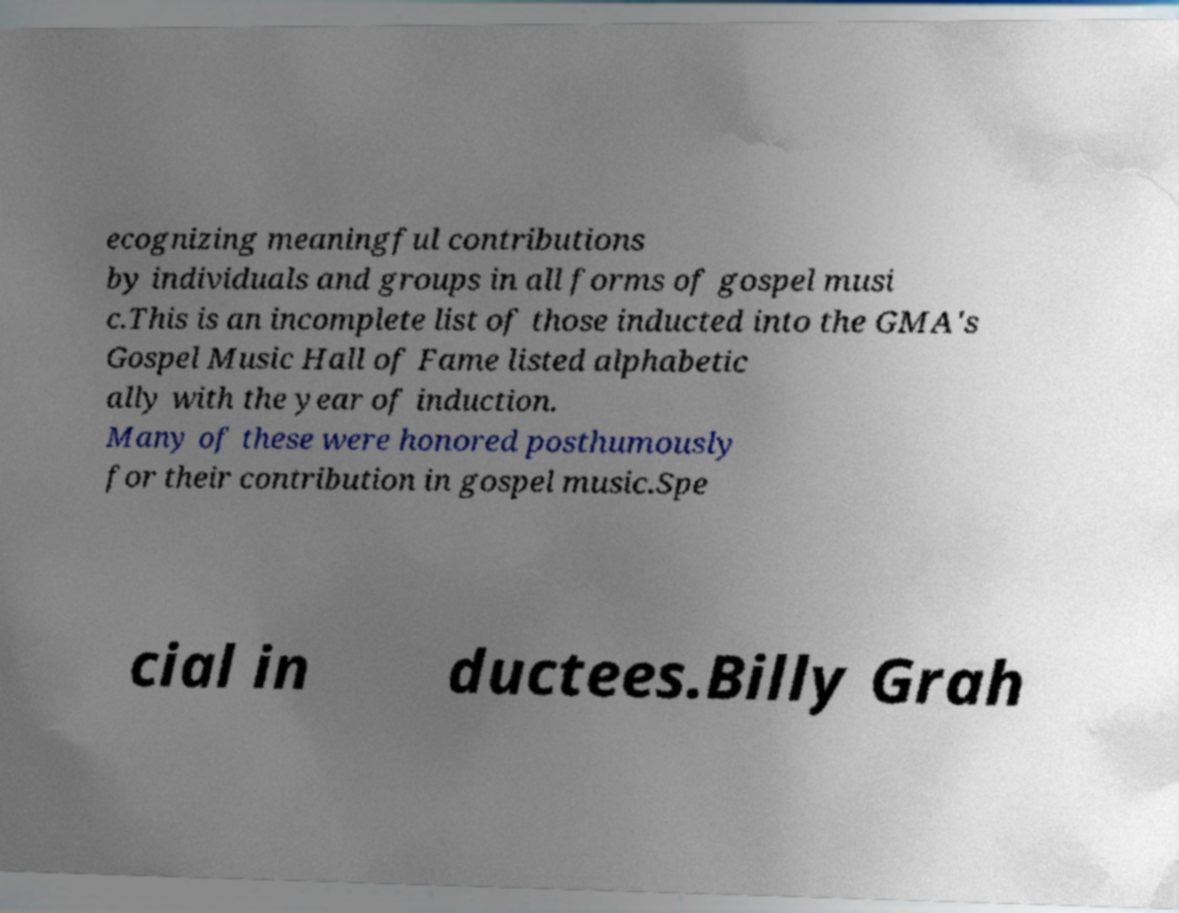For documentation purposes, I need the text within this image transcribed. Could you provide that? ecognizing meaningful contributions by individuals and groups in all forms of gospel musi c.This is an incomplete list of those inducted into the GMA's Gospel Music Hall of Fame listed alphabetic ally with the year of induction. Many of these were honored posthumously for their contribution in gospel music.Spe cial in ductees.Billy Grah 